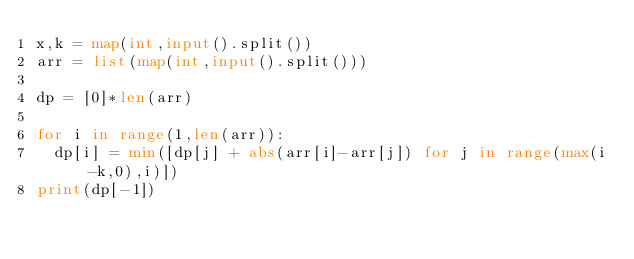<code> <loc_0><loc_0><loc_500><loc_500><_Python_>x,k = map(int,input().split())
arr = list(map(int,input().split()))

dp = [0]*len(arr)

for i in range(1,len(arr)):
  dp[i] = min([dp[j] + abs(arr[i]-arr[j]) for j in range(max(i-k,0),i)])
print(dp[-1])</code> 